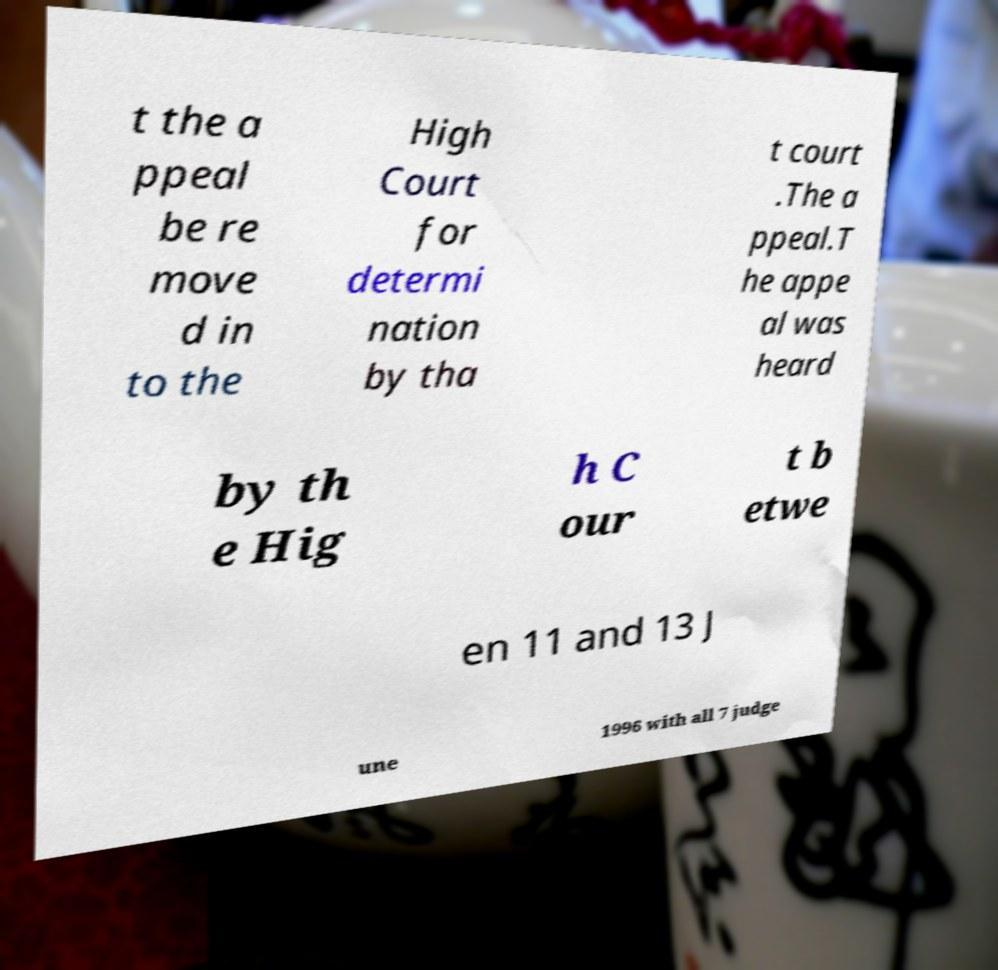Could you extract and type out the text from this image? t the a ppeal be re move d in to the High Court for determi nation by tha t court .The a ppeal.T he appe al was heard by th e Hig h C our t b etwe en 11 and 13 J une 1996 with all 7 judge 